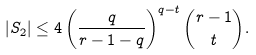<formula> <loc_0><loc_0><loc_500><loc_500>| S _ { 2 } | \leq 4 \left ( \frac { q } { r - 1 - q } \right ) ^ { q - t } \binom { r - 1 } { t } .</formula> 